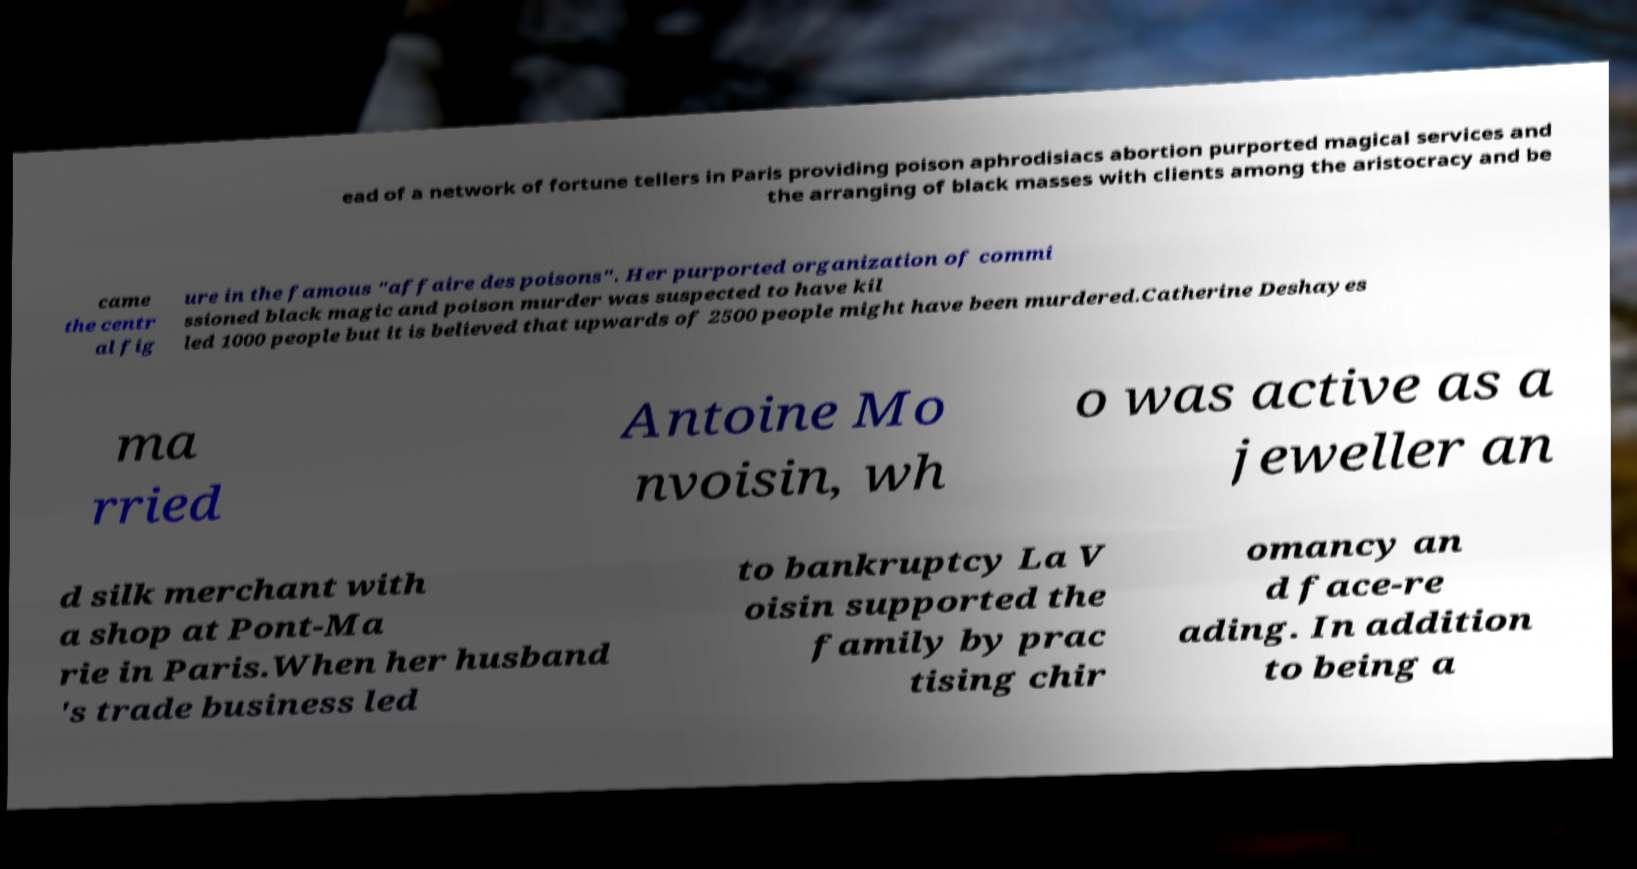I need the written content from this picture converted into text. Can you do that? ead of a network of fortune tellers in Paris providing poison aphrodisiacs abortion purported magical services and the arranging of black masses with clients among the aristocracy and be came the centr al fig ure in the famous "affaire des poisons". Her purported organization of commi ssioned black magic and poison murder was suspected to have kil led 1000 people but it is believed that upwards of 2500 people might have been murdered.Catherine Deshayes ma rried Antoine Mo nvoisin, wh o was active as a jeweller an d silk merchant with a shop at Pont-Ma rie in Paris.When her husband 's trade business led to bankruptcy La V oisin supported the family by prac tising chir omancy an d face-re ading. In addition to being a 